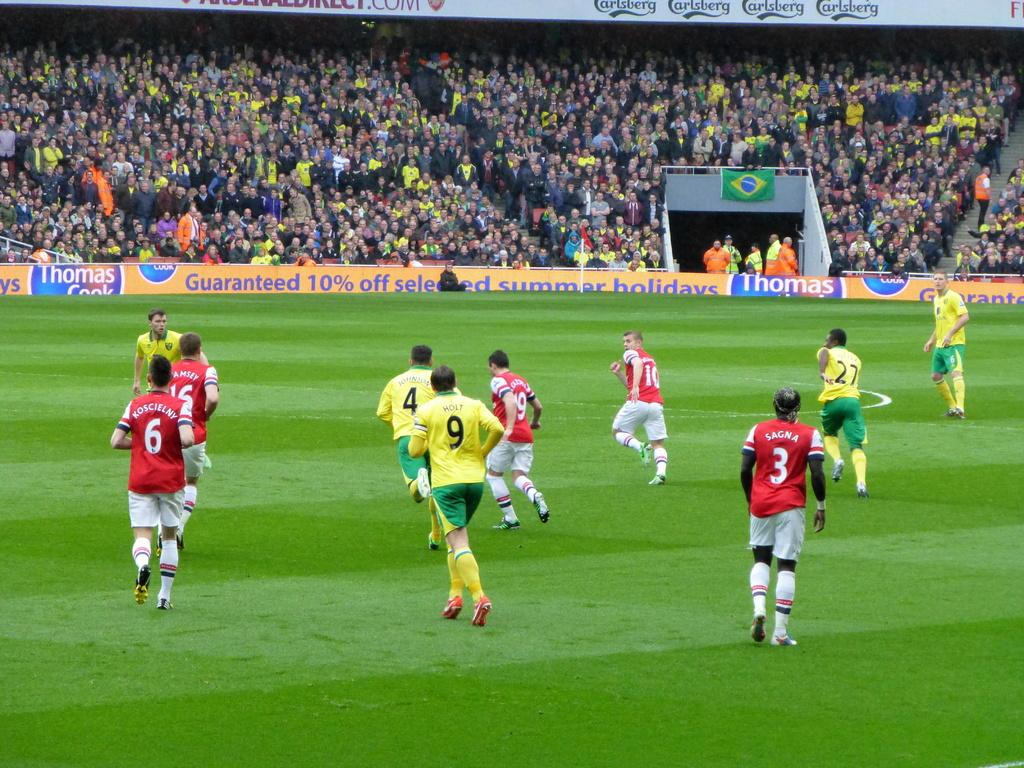<image>
Provide a brief description of the given image. a soccer game with a banner on the sideline that says 'thomas 